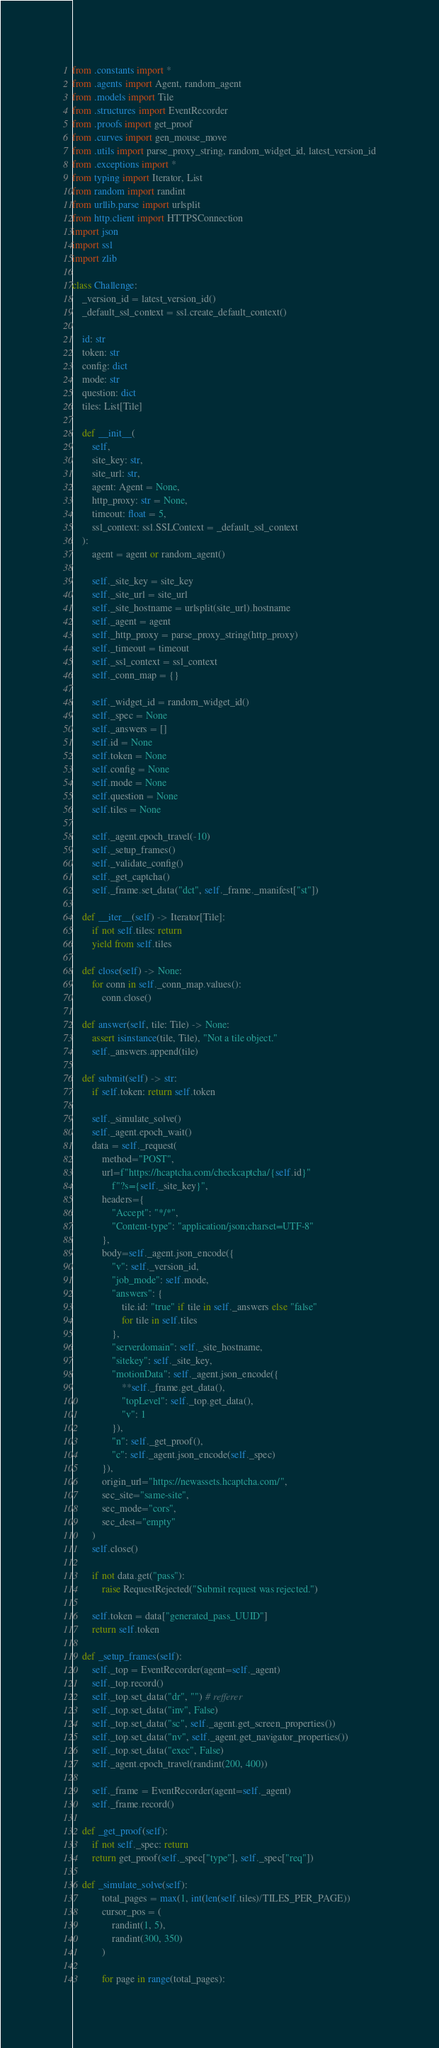<code> <loc_0><loc_0><loc_500><loc_500><_Python_>from .constants import *
from .agents import Agent, random_agent
from .models import Tile
from .structures import EventRecorder
from .proofs import get_proof
from .curves import gen_mouse_move
from .utils import parse_proxy_string, random_widget_id, latest_version_id
from .exceptions import *
from typing import Iterator, List
from random import randint
from urllib.parse import urlsplit
from http.client import HTTPSConnection
import json
import ssl
import zlib

class Challenge:
    _version_id = latest_version_id()
    _default_ssl_context = ssl.create_default_context()

    id: str
    token: str
    config: dict
    mode: str
    question: dict
    tiles: List[Tile]

    def __init__(
        self,
        site_key: str,
        site_url: str,
        agent: Agent = None,
        http_proxy: str = None,
        timeout: float = 5,
        ssl_context: ssl.SSLContext = _default_ssl_context
    ):
        agent = agent or random_agent()

        self._site_key = site_key
        self._site_url = site_url
        self._site_hostname = urlsplit(site_url).hostname
        self._agent = agent
        self._http_proxy = parse_proxy_string(http_proxy)
        self._timeout = timeout
        self._ssl_context = ssl_context
        self._conn_map = {}

        self._widget_id = random_widget_id()
        self._spec = None
        self._answers = []
        self.id = None
        self.token = None
        self.config = None
        self.mode = None
        self.question = None
        self.tiles = None

        self._agent.epoch_travel(-10)
        self._setup_frames()
        self._validate_config()
        self._get_captcha()
        self._frame.set_data("dct", self._frame._manifest["st"])

    def __iter__(self) -> Iterator[Tile]:
        if not self.tiles: return
        yield from self.tiles

    def close(self) -> None:
        for conn in self._conn_map.values():
            conn.close()

    def answer(self, tile: Tile) -> None:
        assert isinstance(tile, Tile), "Not a tile object."
        self._answers.append(tile)
    
    def submit(self) -> str:
        if self.token: return self.token
    
        self._simulate_solve()
        self._agent.epoch_wait()
        data = self._request(
            method="POST",
            url=f"https://hcaptcha.com/checkcaptcha/{self.id}"
                f"?s={self._site_key}",
            headers={
                "Accept": "*/*",
                "Content-type": "application/json;charset=UTF-8"
            },
            body=self._agent.json_encode({
                "v": self._version_id,
                "job_mode": self.mode,
                "answers": {
                    tile.id: "true" if tile in self._answers else "false"
                    for tile in self.tiles
                },
                "serverdomain": self._site_hostname,
                "sitekey": self._site_key,
                "motionData": self._agent.json_encode({
                    **self._frame.get_data(),
                    "topLevel": self._top.get_data(),
                    "v": 1
                }),
                "n": self._get_proof(),
                "c": self._agent.json_encode(self._spec)
            }),
            origin_url="https://newassets.hcaptcha.com/",
            sec_site="same-site",
            sec_mode="cors",
            sec_dest="empty"
        )
        self.close()

        if not data.get("pass"):
            raise RequestRejected("Submit request was rejected.")

        self.token = data["generated_pass_UUID"]
        return self.token

    def _setup_frames(self):
        self._top = EventRecorder(agent=self._agent)
        self._top.record()
        self._top.set_data("dr", "") # refferer
        self._top.set_data("inv", False)
        self._top.set_data("sc", self._agent.get_screen_properties())
        self._top.set_data("nv", self._agent.get_navigator_properties())
        self._top.set_data("exec", False)
        self._agent.epoch_travel(randint(200, 400))

        self._frame = EventRecorder(agent=self._agent)
        self._frame.record()

    def _get_proof(self):
        if not self._spec: return
        return get_proof(self._spec["type"], self._spec["req"])

    def _simulate_solve(self):
            total_pages = max(1, int(len(self.tiles)/TILES_PER_PAGE))
            cursor_pos = (
                randint(1, 5),
                randint(300, 350)
            )

            for page in range(total_pages):</code> 